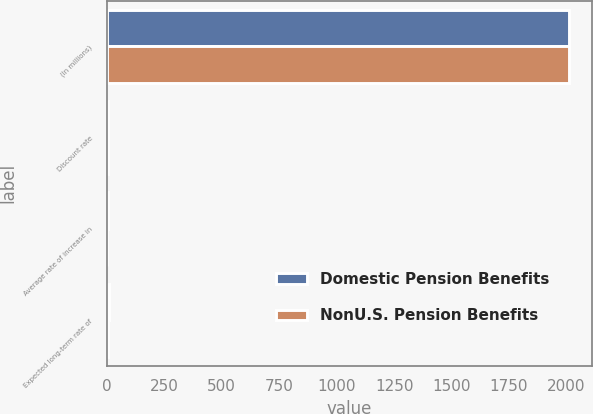Convert chart to OTSL. <chart><loc_0><loc_0><loc_500><loc_500><stacked_bar_chart><ecel><fcel>(In millions)<fcel>Discount rate<fcel>Average rate of increase in<fcel>Expected long-term rate of<nl><fcel>Domestic Pension Benefits<fcel>2012<fcel>4.5<fcel>4<fcel>7.75<nl><fcel>NonU.S. Pension Benefits<fcel>2012<fcel>4.37<fcel>3.23<fcel>5.17<nl></chart> 